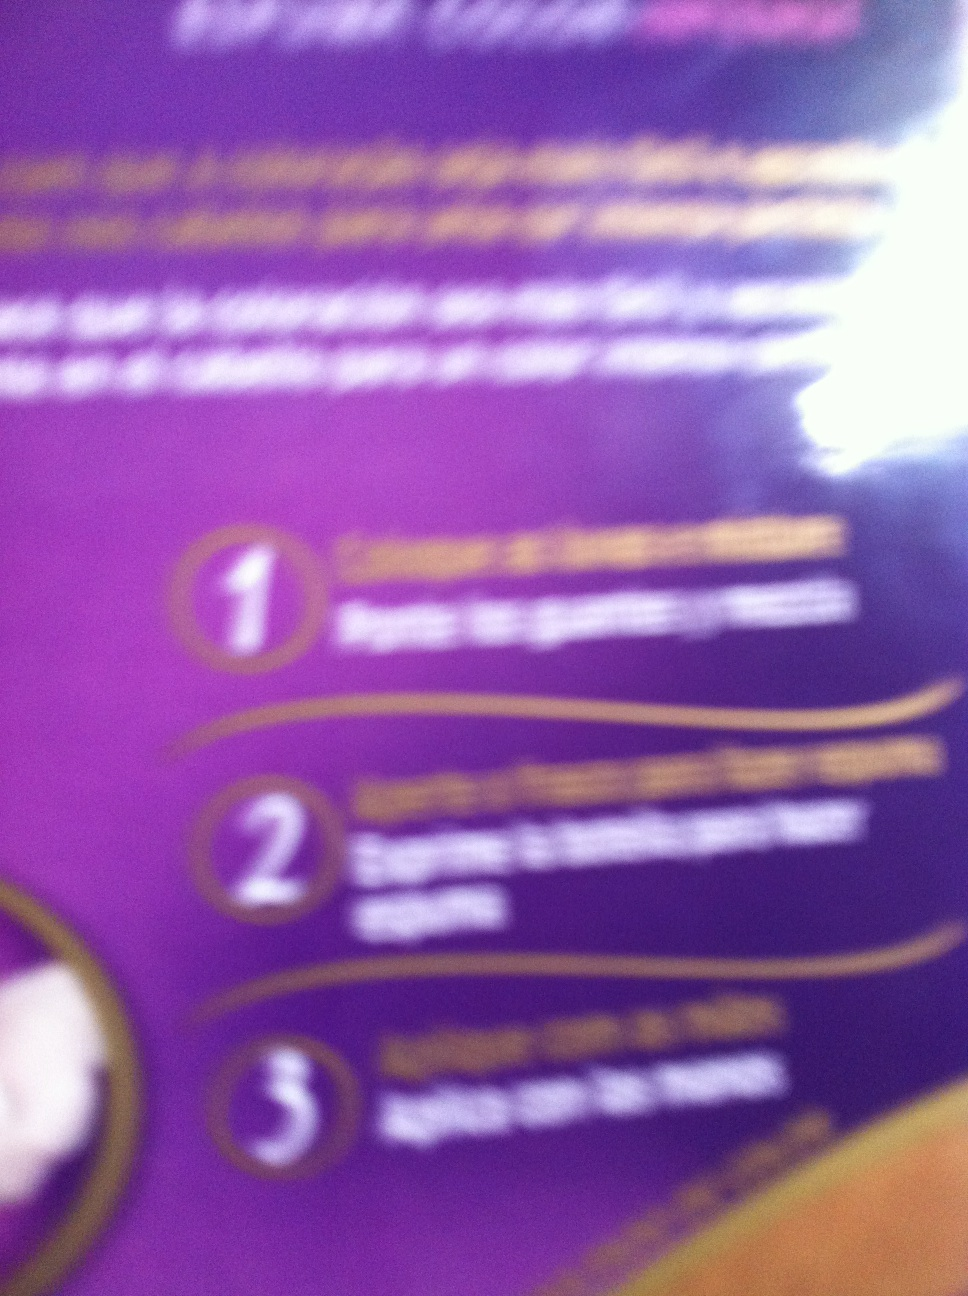I'm not sure how clear this picture is. Can you help me understand what's on this packaging label? The image appears slightly blurred, but it seems to be instructions for a product. It looks like it has a step-by-step guide. Here’s a general interpretation: 
1. Apply the product generously on the desired area.
2. Ensure it is spread evenly.
3. Wait for it to fully absorb for optimal benefits. 